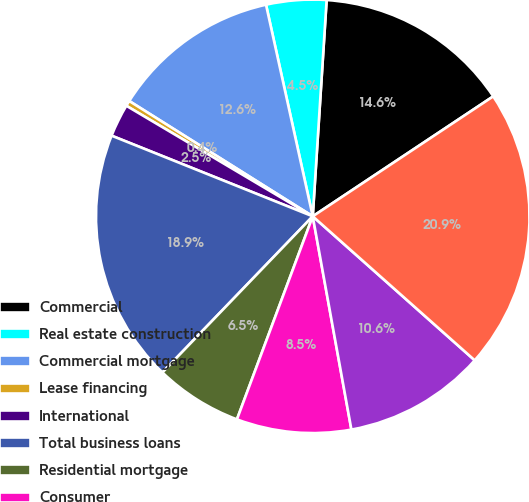Convert chart to OTSL. <chart><loc_0><loc_0><loc_500><loc_500><pie_chart><fcel>Commercial<fcel>Real estate construction<fcel>Commercial mortgage<fcel>Lease financing<fcel>International<fcel>Total business loans<fcel>Residential mortgage<fcel>Consumer<fcel>Total retail loans<fcel>Total loans<nl><fcel>14.64%<fcel>4.48%<fcel>12.61%<fcel>0.41%<fcel>2.45%<fcel>18.87%<fcel>6.51%<fcel>8.54%<fcel>10.58%<fcel>20.9%<nl></chart> 